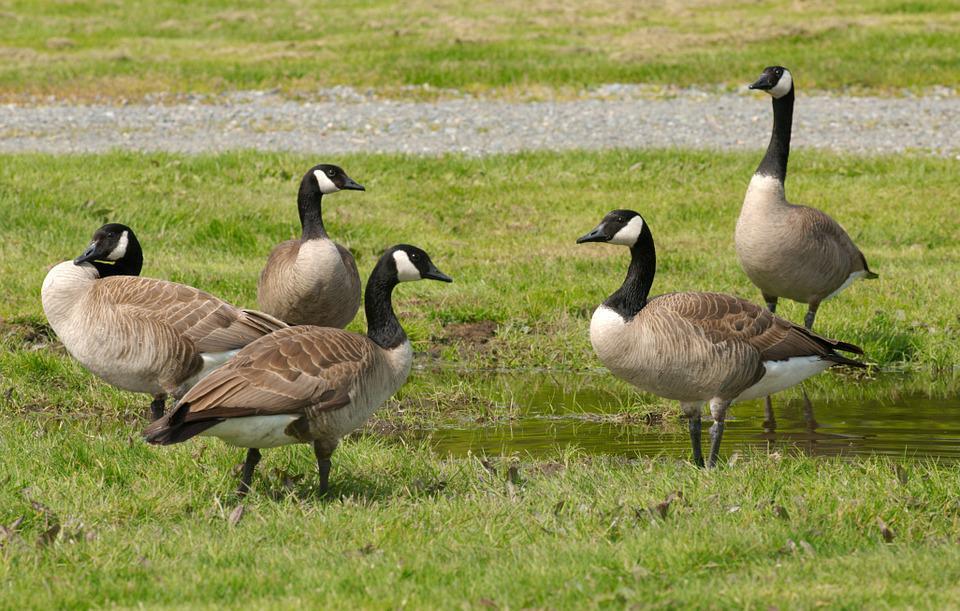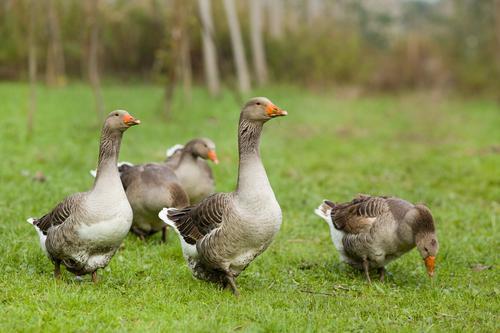The first image is the image on the left, the second image is the image on the right. Given the left and right images, does the statement "In the right image, there are two Canadian geese." hold true? Answer yes or no. No. The first image is the image on the left, the second image is the image on the right. For the images displayed, is the sentence "the image on the right has 2 geese" factually correct? Answer yes or no. No. 